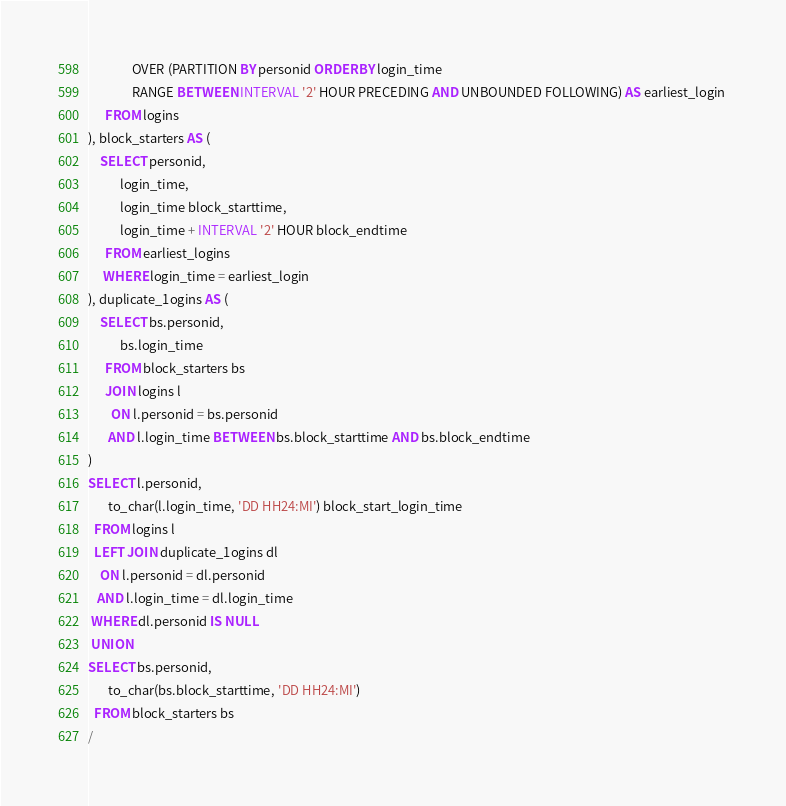<code> <loc_0><loc_0><loc_500><loc_500><_SQL_>       		   OVER (PARTITION BY personid ORDER BY login_time 
       		   RANGE BETWEEN INTERVAL '2' HOUR PRECEDING AND UNBOUNDED FOLLOWING) AS earliest_login 
  	  FROM logins
), block_starters AS (
	SELECT personid,
           login_time,
           login_time block_starttime,
           login_time + INTERVAL '2' HOUR block_endtime 
      FROM earliest_logins
     WHERE login_time = earliest_login
), duplicate_1ogins AS (
    SELECT bs.personid,
           bs.login_time
      FROM block_starters bs
      JOIN logins l
        ON l.personid = bs.personid 
       AND l.login_time BETWEEN bs.block_starttime AND bs.block_endtime
)
SELECT l.personid,
       to_char(l.login_time, 'DD HH24:MI') block_start_login_time
  FROM logins l
  LEFT JOIN duplicate_1ogins dl
    ON l.personid = dl.personid 
   AND l.login_time = dl.login_time
 WHERE dl.personid IS NULL
 UNION
SELECT bs.personid,
       to_char(bs.block_starttime, 'DD HH24:MI')
  FROM block_starters bs
/</code> 